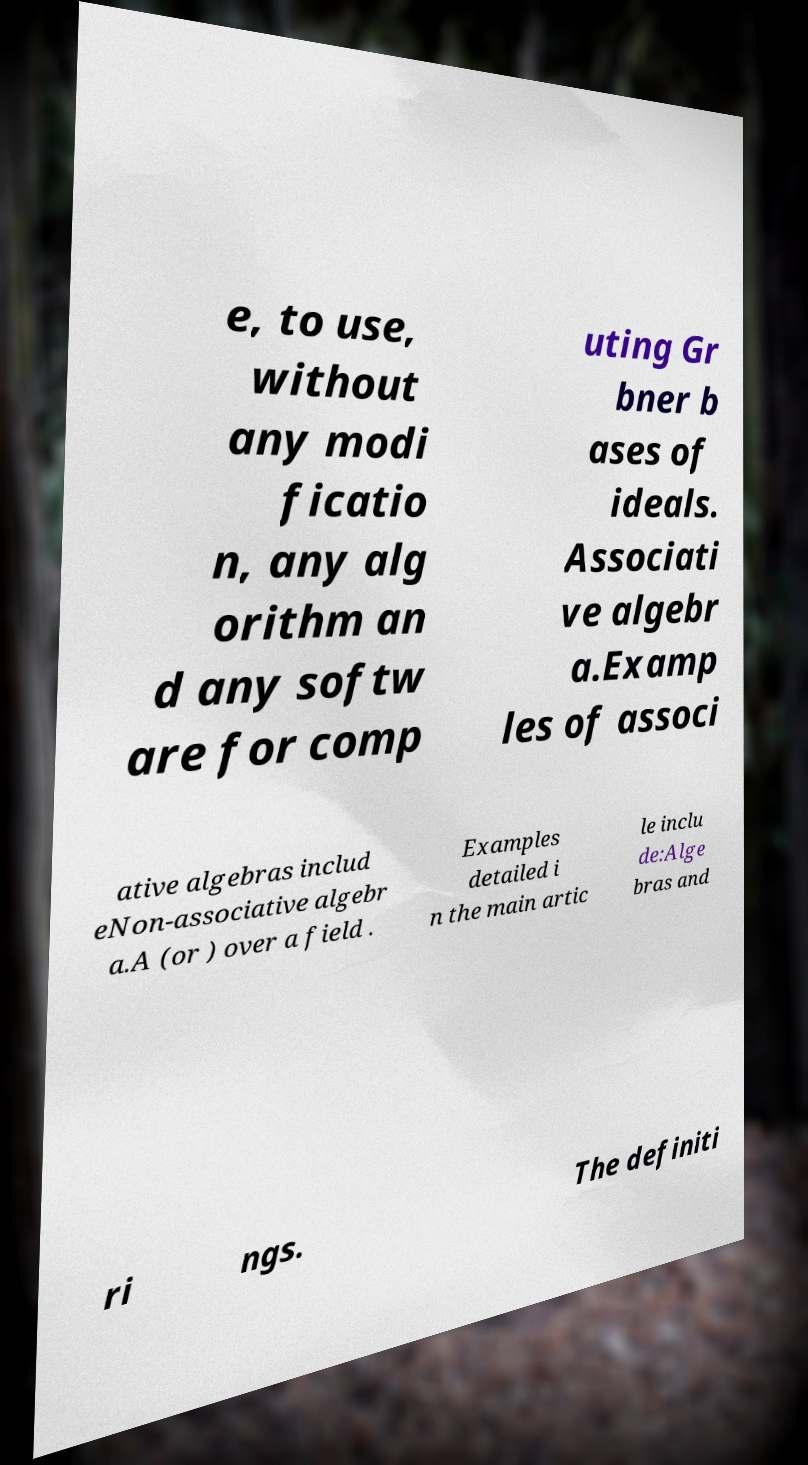Could you extract and type out the text from this image? e, to use, without any modi ficatio n, any alg orithm an d any softw are for comp uting Gr bner b ases of ideals. Associati ve algebr a.Examp les of associ ative algebras includ eNon-associative algebr a.A (or ) over a field . Examples detailed i n the main artic le inclu de:Alge bras and ri ngs. The definiti 